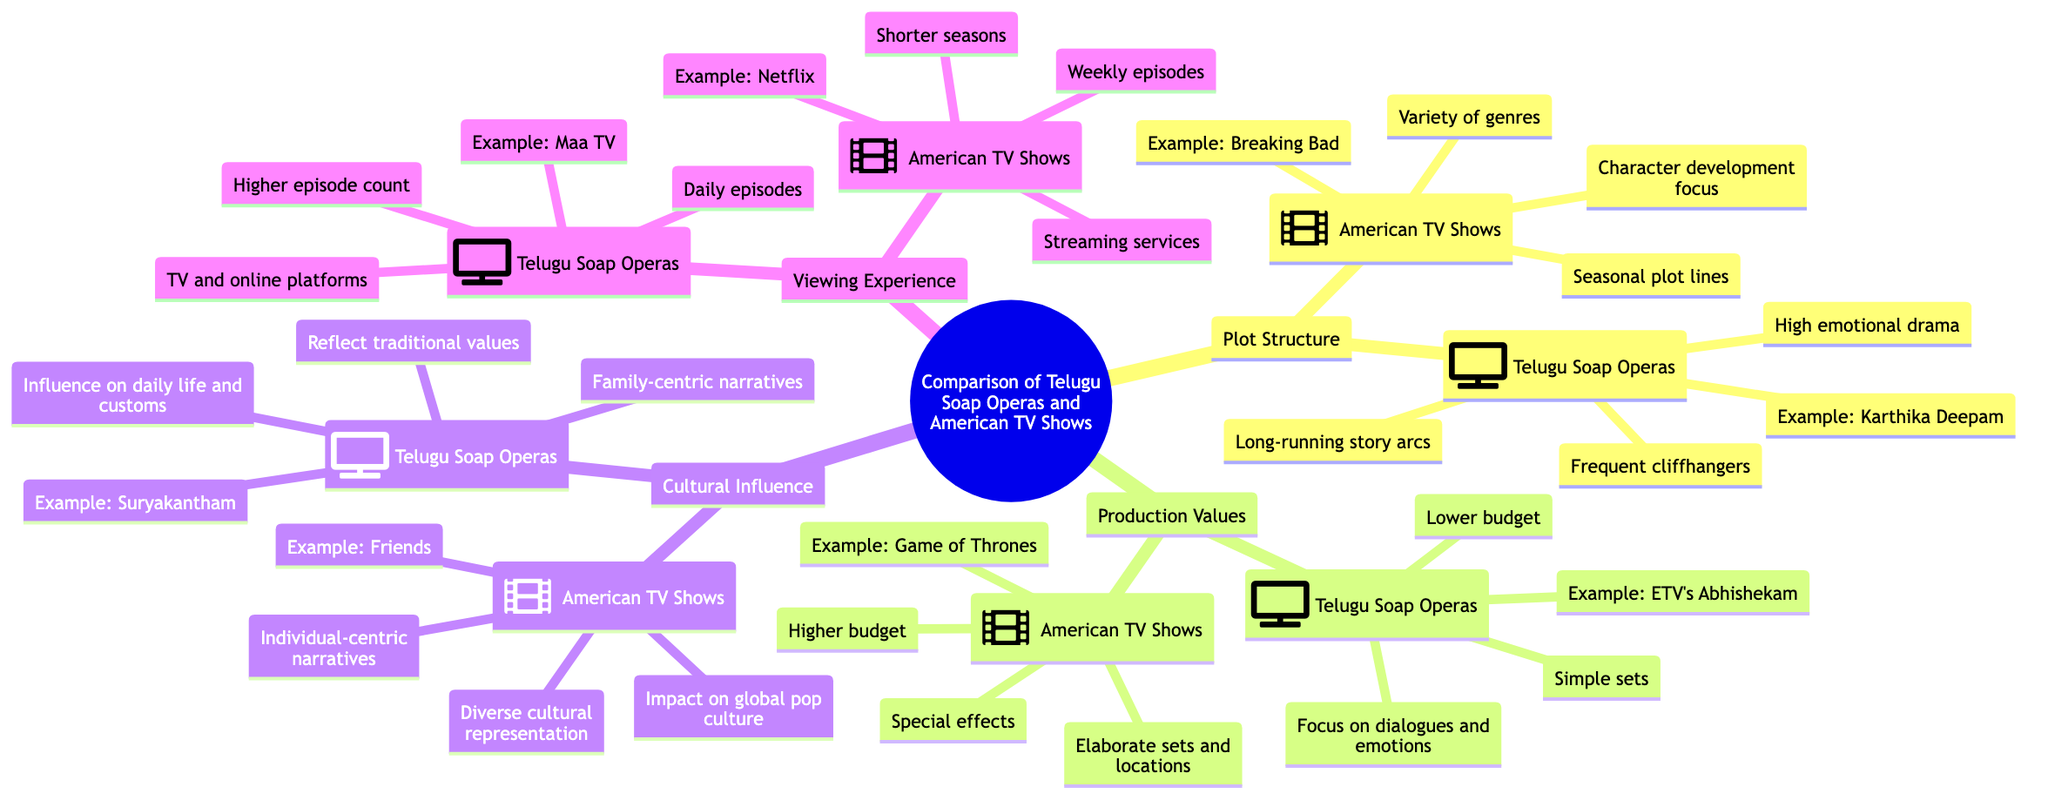What is the central topic of the diagram? The central topic is explicitly labeled at the top of the diagram as "Comparison of Telugu Soap Operas and American TV Shows."
Answer: Comparison of Telugu Soap Operas and American TV Shows How many subtopics are present in the diagram? The diagram contains four subtopics, which are Plot Structure, Production Values, Cultural Influence, and Viewing Experience.
Answer: 4 What example is given for Telugu Soap Operas in the Plot Structure section? In the Plot Structure section under Telugu Soap Operas, the example provided is "Karthika Deepam."
Answer: Karthika Deepam What type of narratives do Telugu Soap Operas focus on according to the Cultural Influence section? The diagram states that Telugu Soap Operas focus on "Family-centric narratives" as part of their cultural influence.
Answer: Family-centric narratives What do American TV Shows primarily represent in terms of culture? The American TV Shows section indicates that they provide "Diverse cultural representation."
Answer: Diverse cultural representation Which production has a higher budget, Telugu Soap Operas or American TV Shows? The diagram clearly states that American TV Shows have a "Higher budget" compared to Telugu Soap Operas, which have a "Lower budget."
Answer: Higher budget What is the typical episode frequency for Telugu Soap Operas? According to the Viewing Experience section, Telugu Soap Operas typically feature "Daily episodes."
Answer: Daily episodes How do viewing platforms differ for Telugu Soap Operas and American TV Shows? The diagram specifies that Telugu Soap Operas are shown on "TV and online platforms," whereas American TV Shows are primarily on "Streaming services."
Answer: TV and online platforms; Streaming services What is an example of an American TV Show mentioned in the Production Values section? In the Production Values section for American TV Shows, the example given is "Game of Thrones."
Answer: Game of Thrones 